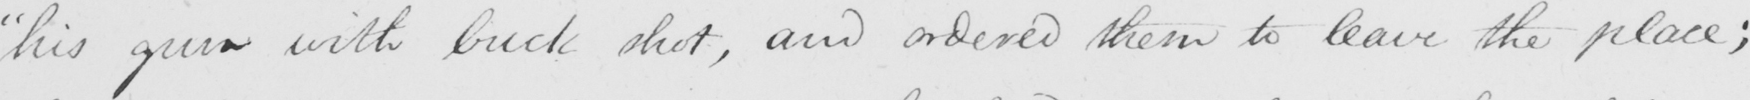Can you tell me what this handwritten text says? " his gun with buck shot , and ordered them to leave the place ; 